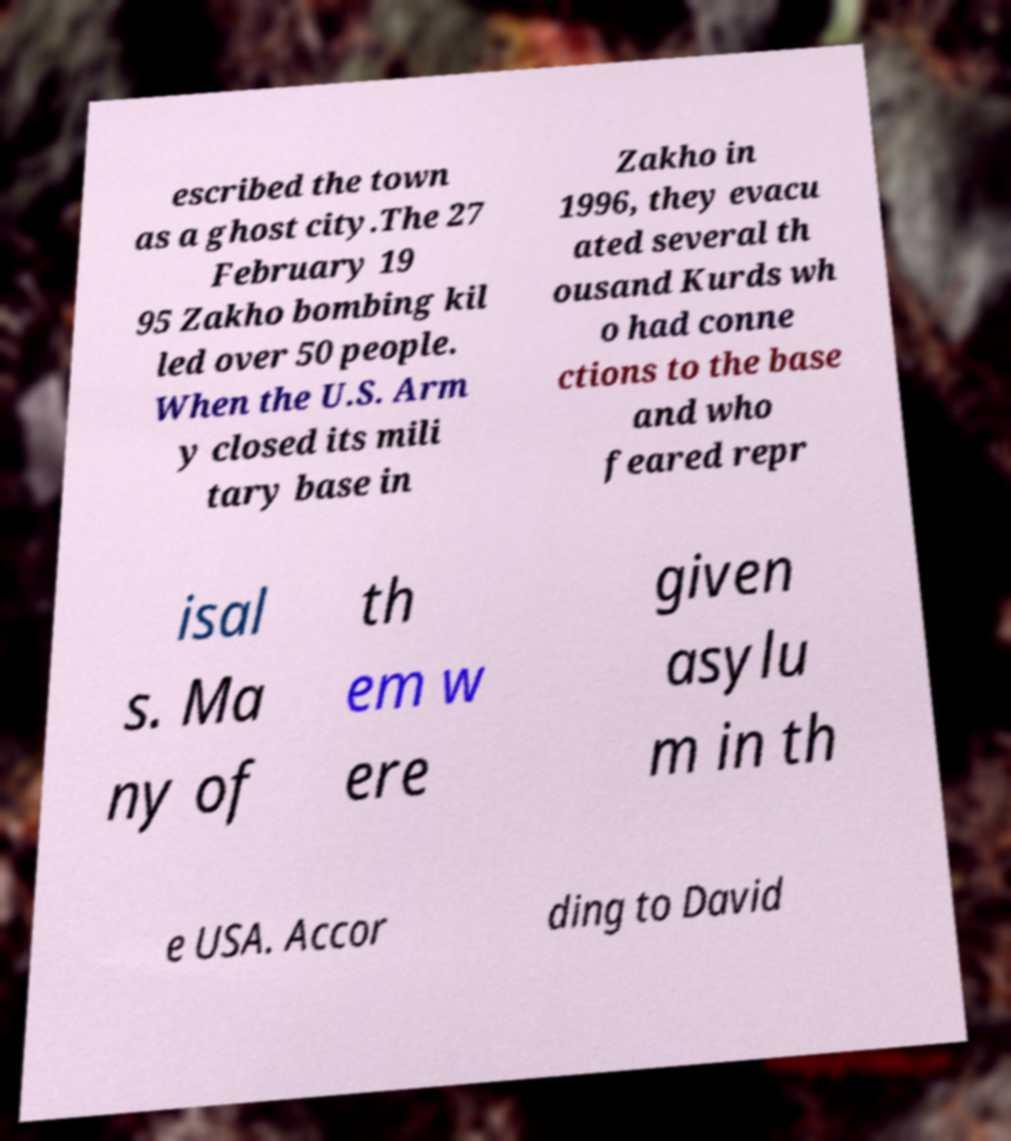For documentation purposes, I need the text within this image transcribed. Could you provide that? escribed the town as a ghost city.The 27 February 19 95 Zakho bombing kil led over 50 people. When the U.S. Arm y closed its mili tary base in Zakho in 1996, they evacu ated several th ousand Kurds wh o had conne ctions to the base and who feared repr isal s. Ma ny of th em w ere given asylu m in th e USA. Accor ding to David 